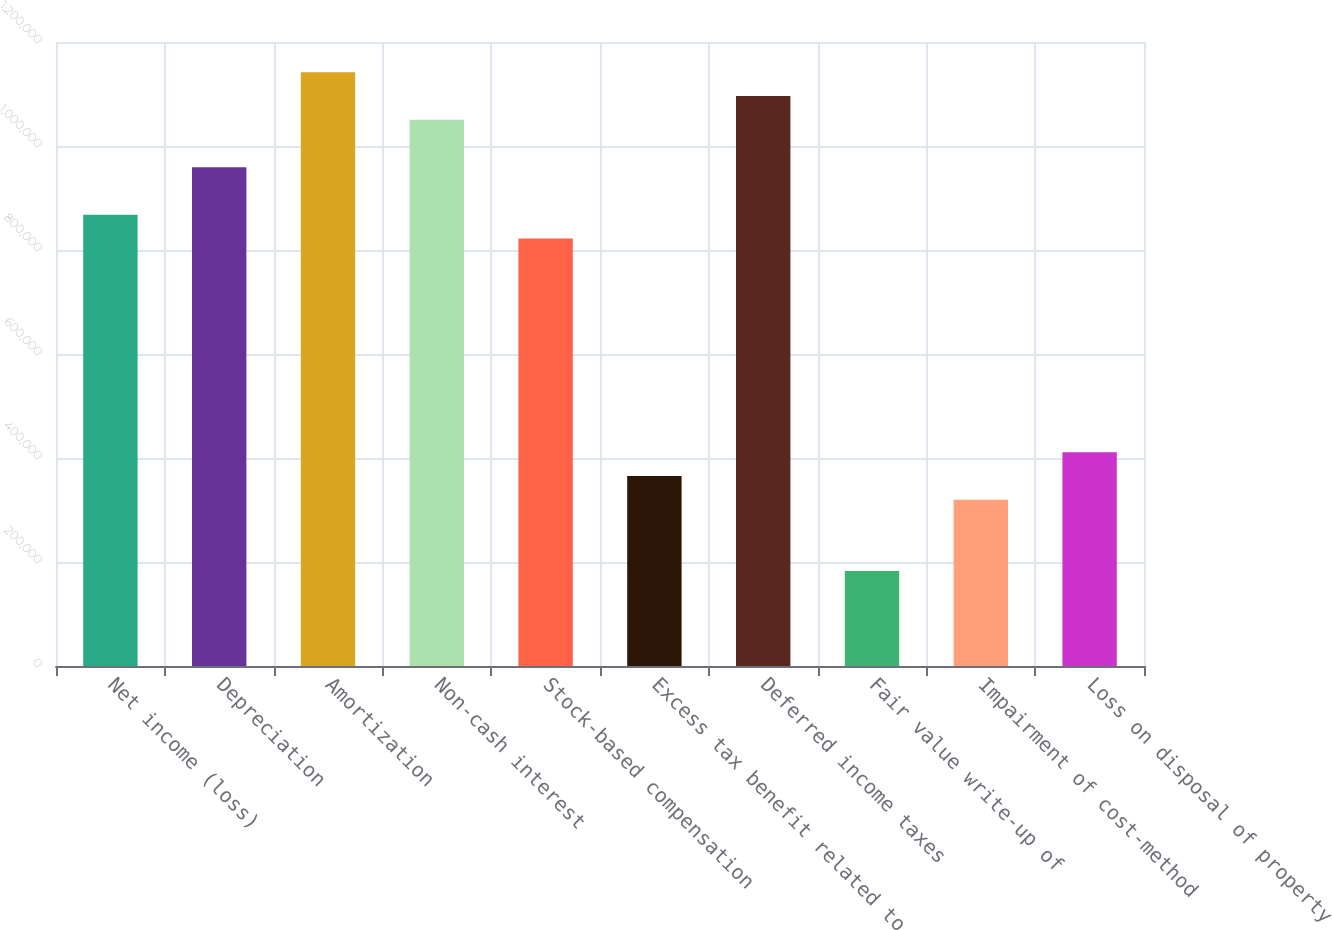Convert chart. <chart><loc_0><loc_0><loc_500><loc_500><bar_chart><fcel>Net income (loss)<fcel>Depreciation<fcel>Amortization<fcel>Non-cash interest<fcel>Stock-based compensation<fcel>Excess tax benefit related to<fcel>Deferred income taxes<fcel>Fair value write-up of<fcel>Impairment of cost-method<fcel>Loss on disposal of property<nl><fcel>867729<fcel>959067<fcel>1.14174e+06<fcel>1.0504e+06<fcel>822061<fcel>365375<fcel>1.09607e+06<fcel>182700<fcel>319706<fcel>411043<nl></chart> 